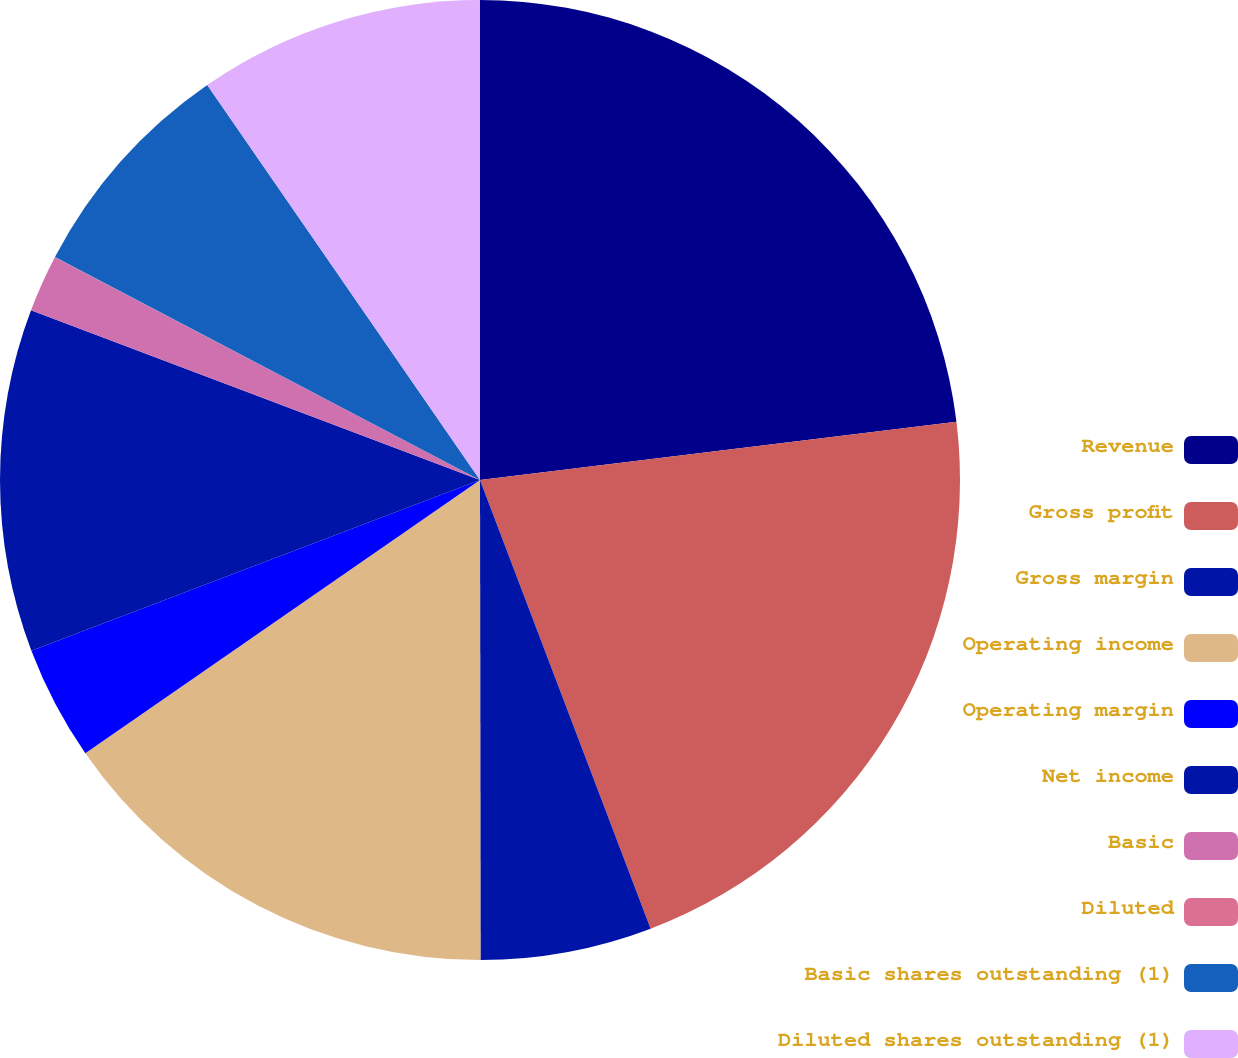<chart> <loc_0><loc_0><loc_500><loc_500><pie_chart><fcel>Revenue<fcel>Gross profit<fcel>Gross margin<fcel>Operating income<fcel>Operating margin<fcel>Net income<fcel>Basic<fcel>Diluted<fcel>Basic shares outstanding (1)<fcel>Diluted shares outstanding (1)<nl><fcel>23.07%<fcel>21.15%<fcel>5.77%<fcel>15.38%<fcel>3.85%<fcel>11.54%<fcel>1.93%<fcel>0.01%<fcel>7.69%<fcel>9.62%<nl></chart> 